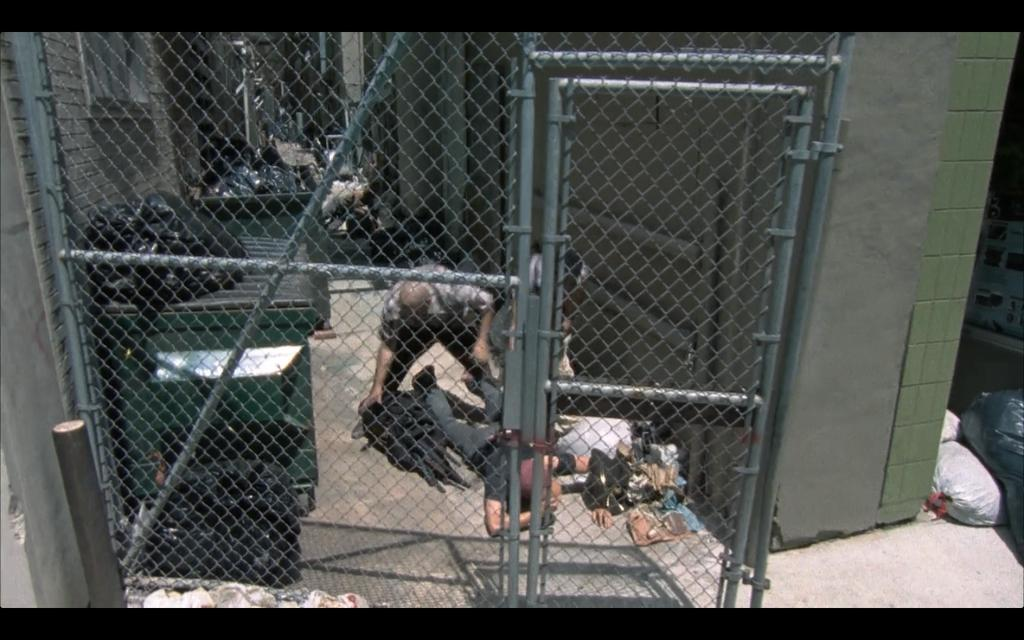What type of door is visible in the image? There is a mesh door in the image. What kind of location is depicted in the image? The area appears to be a dump yard. What activity is taking place in the dump yard? Two men are fighting inside the dump yard. What can be observed about the environment in the image? There is a lot of trash in the dump yard area. How many people are pushing a bridge in the image? There is no bridge or pushing activity present in the image. 